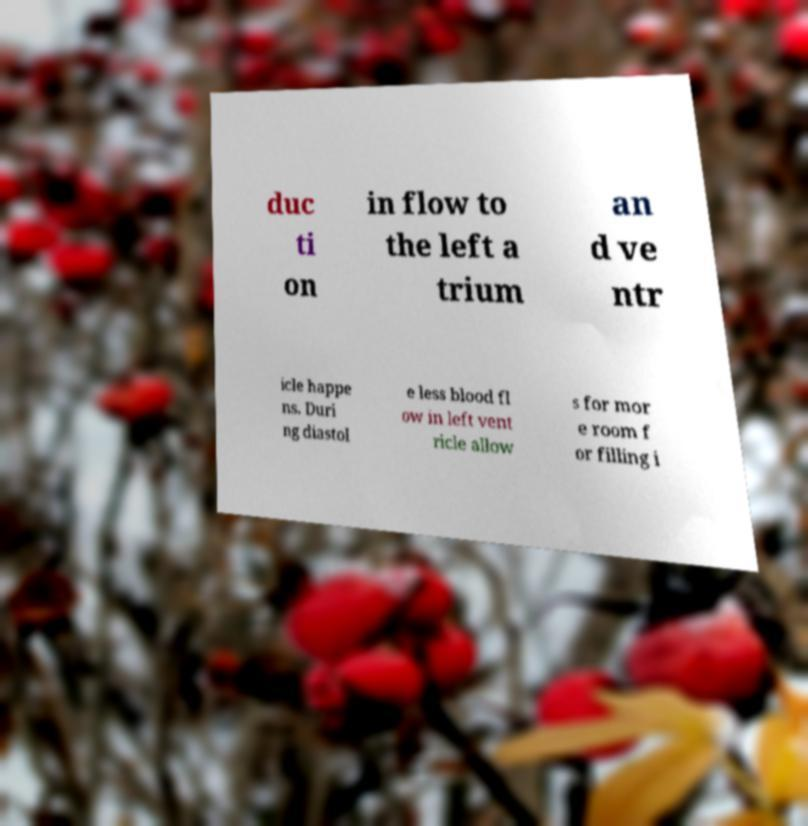Can you read and provide the text displayed in the image?This photo seems to have some interesting text. Can you extract and type it out for me? duc ti on in flow to the left a trium an d ve ntr icle happe ns. Duri ng diastol e less blood fl ow in left vent ricle allow s for mor e room f or filling i 